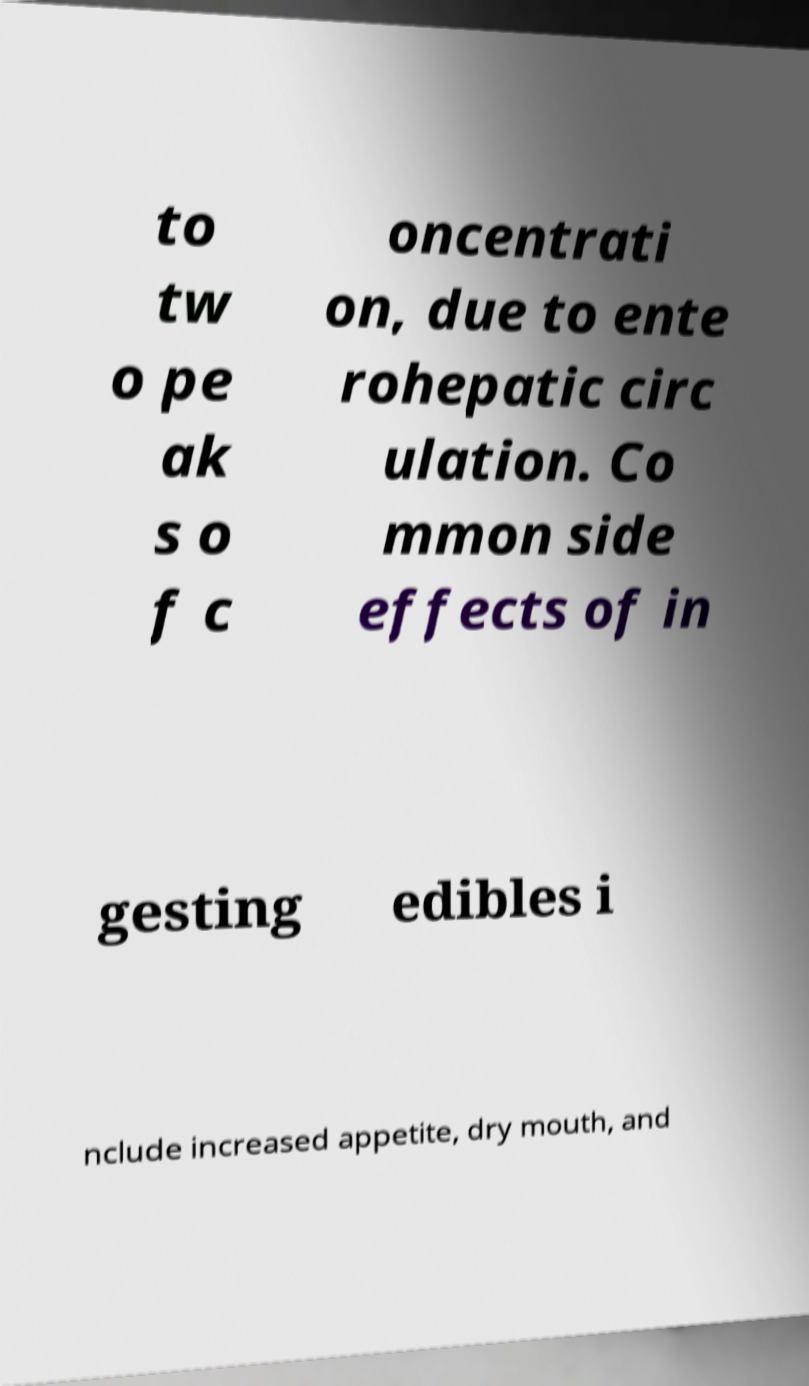Please identify and transcribe the text found in this image. to tw o pe ak s o f c oncentrati on, due to ente rohepatic circ ulation. Co mmon side effects of in gesting edibles i nclude increased appetite, dry mouth, and 